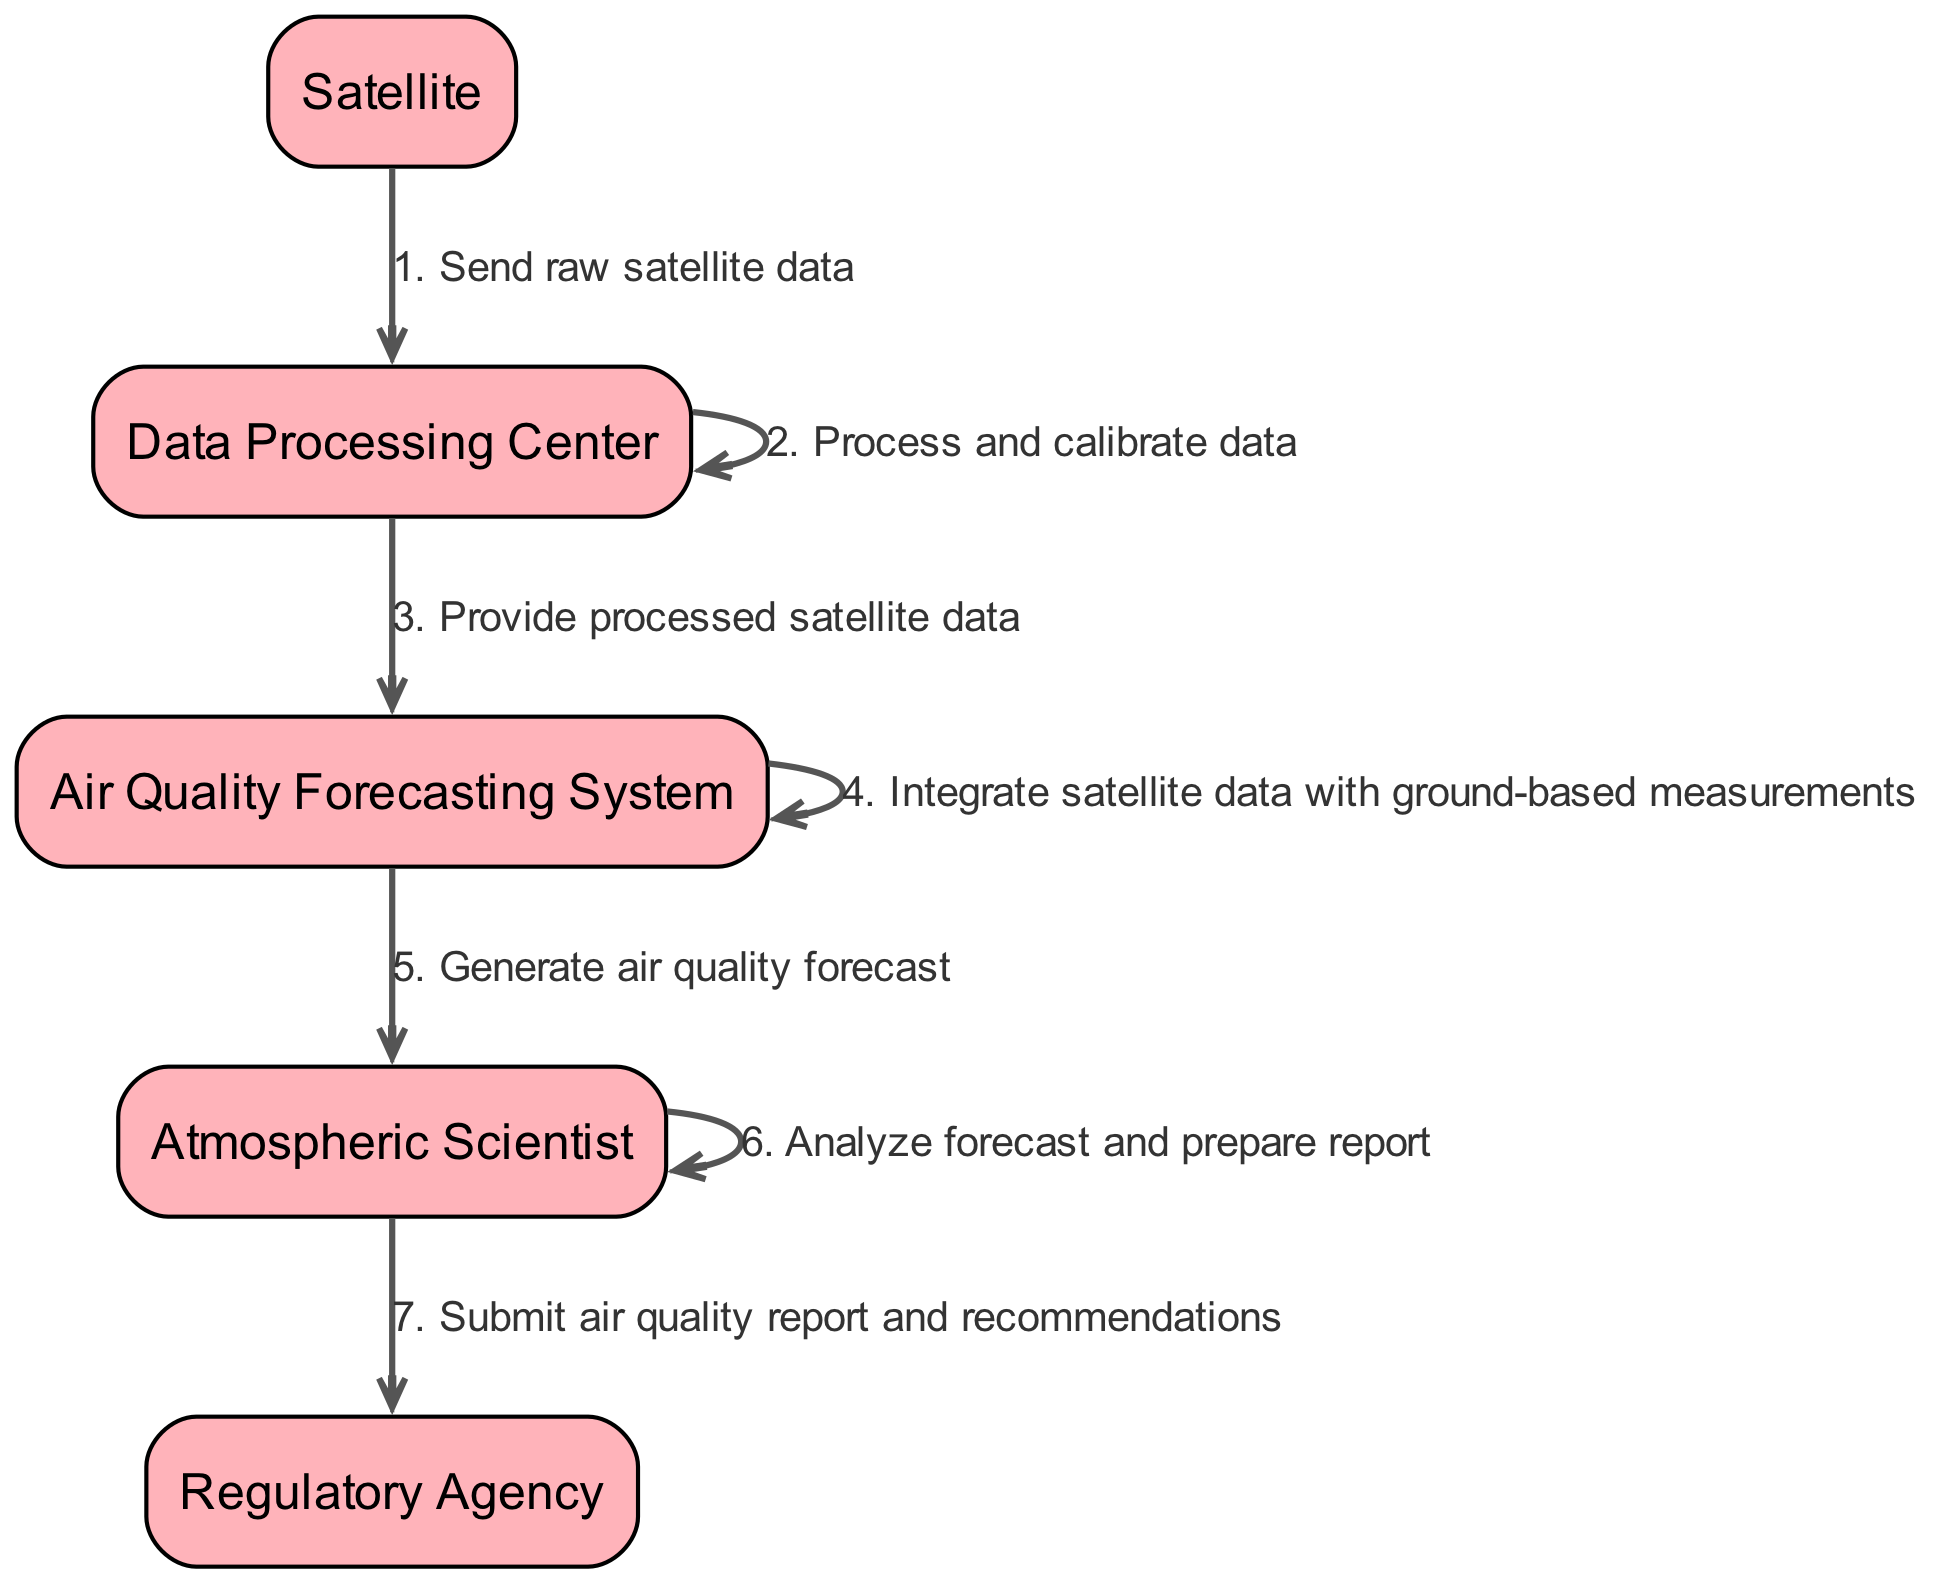What is the first actor to send a message? The first actor in the sequence diagram is the Satellite, as it sends the raw satellite data to the Data Processing Center.
Answer: Satellite How many messages are sent from the Data Processing Center? The Data Processing Center sends two messages: one to itself (for processing and calibration) and one to the Air Quality Forecasting System.
Answer: 2 Who is responsible for generating the air quality forecast? The Air Quality Forecasting System is responsible for generating the air quality forecast after integrating the satellite data with ground-based measurements.
Answer: Air Quality Forecasting System What action does the Atmospheric Scientist take after generating the forecast? The Atmospheric Scientist analyzes the generated air quality forecast and prepares a report.
Answer: Analyze forecast and prepare report Order of actions: What is the sequence of actions taken from receiving satellite data to submitting a report? The sequence starts with the Satellite sending raw data to the Data Processing Center, which then processes the data. After processing, it sends the data to the Air Quality Forecasting System, which integrates the data and generates a forecast. Finally, the Atmospheric Scientist analyzes the forecast and submits the report to the Regulatory Agency.
Answer: Satellite → Data Processing Center → Air Quality Forecasting System → Atmospheric Scientist → Regulatory Agency What type of data is sent from the Satellite to the Data Processing Center? The data sent from the Satellite to the Data Processing Center is described as raw satellite data.
Answer: Raw satellite data How many actors are involved in the sequence? The sequence diagram includes five distinct actors: Satellite, Data Processing Center, Air Quality Forecasting System, Atmospheric Scientist, and Regulatory Agency.
Answer: 5 What is the final action taken in the sequence? The final action in the sequence is the Atmospheric Scientist submitting the air quality report and recommendations to the Regulatory Agency.
Answer: Submit air quality report and recommendations 